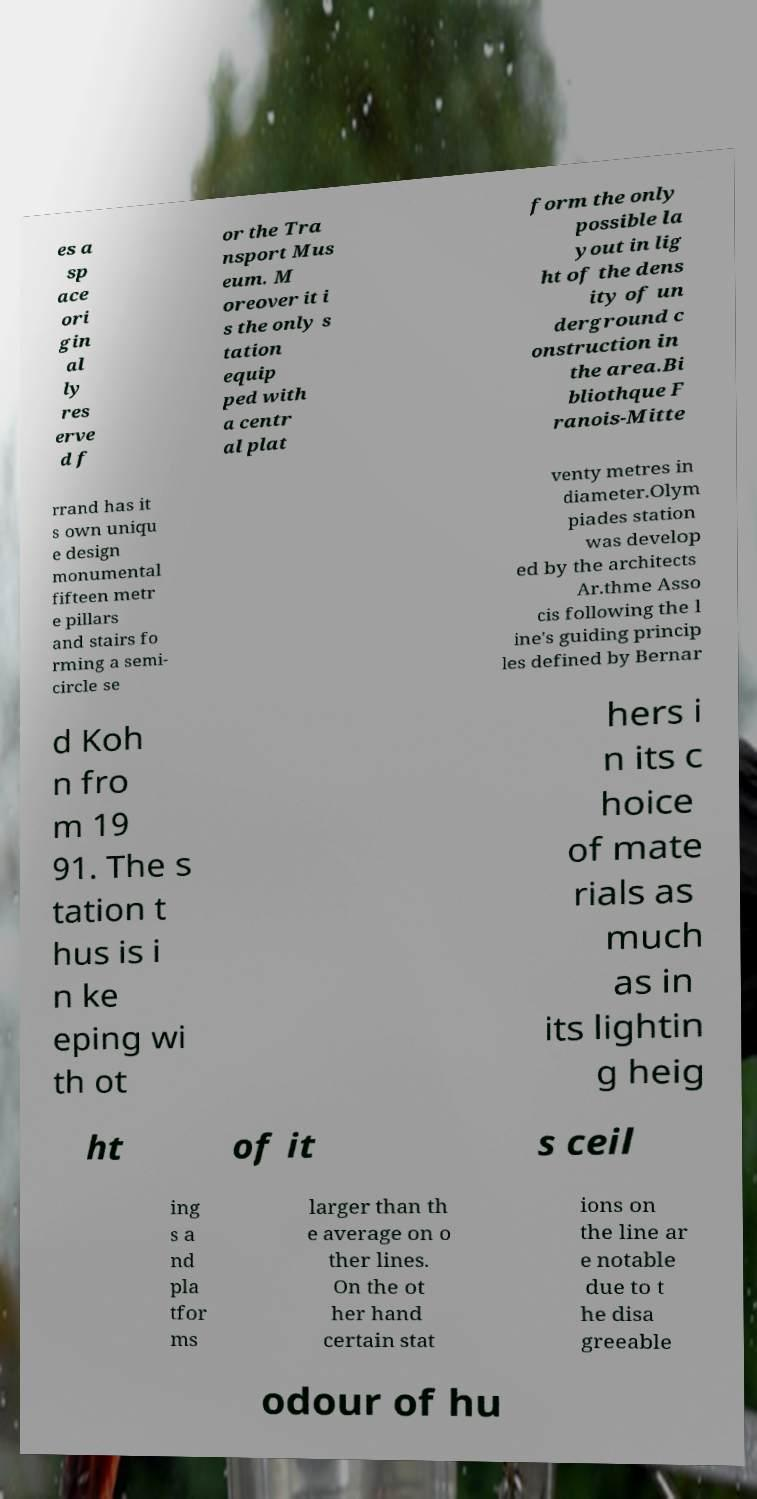For documentation purposes, I need the text within this image transcribed. Could you provide that? es a sp ace ori gin al ly res erve d f or the Tra nsport Mus eum. M oreover it i s the only s tation equip ped with a centr al plat form the only possible la yout in lig ht of the dens ity of un derground c onstruction in the area.Bi bliothque F ranois-Mitte rrand has it s own uniqu e design monumental fifteen metr e pillars and stairs fo rming a semi- circle se venty metres in diameter.Olym piades station was develop ed by the architects Ar.thme Asso cis following the l ine's guiding princip les defined by Bernar d Koh n fro m 19 91. The s tation t hus is i n ke eping wi th ot hers i n its c hoice of mate rials as much as in its lightin g heig ht of it s ceil ing s a nd pla tfor ms larger than th e average on o ther lines. On the ot her hand certain stat ions on the line ar e notable due to t he disa greeable odour of hu 